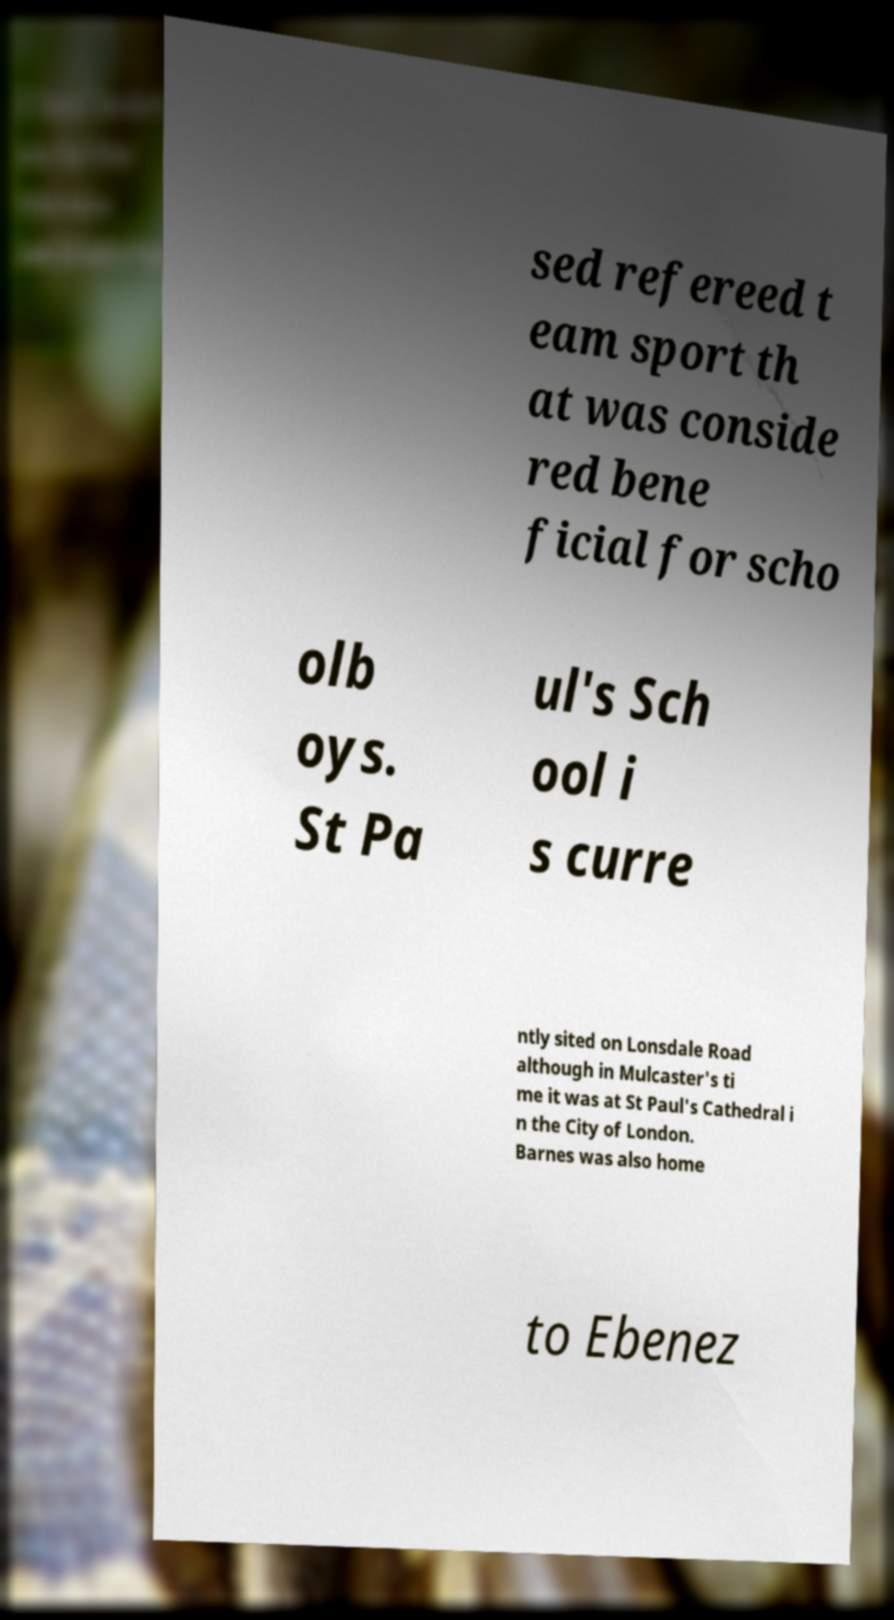Please read and relay the text visible in this image. What does it say? sed refereed t eam sport th at was conside red bene ficial for scho olb oys. St Pa ul's Sch ool i s curre ntly sited on Lonsdale Road although in Mulcaster's ti me it was at St Paul's Cathedral i n the City of London. Barnes was also home to Ebenez 